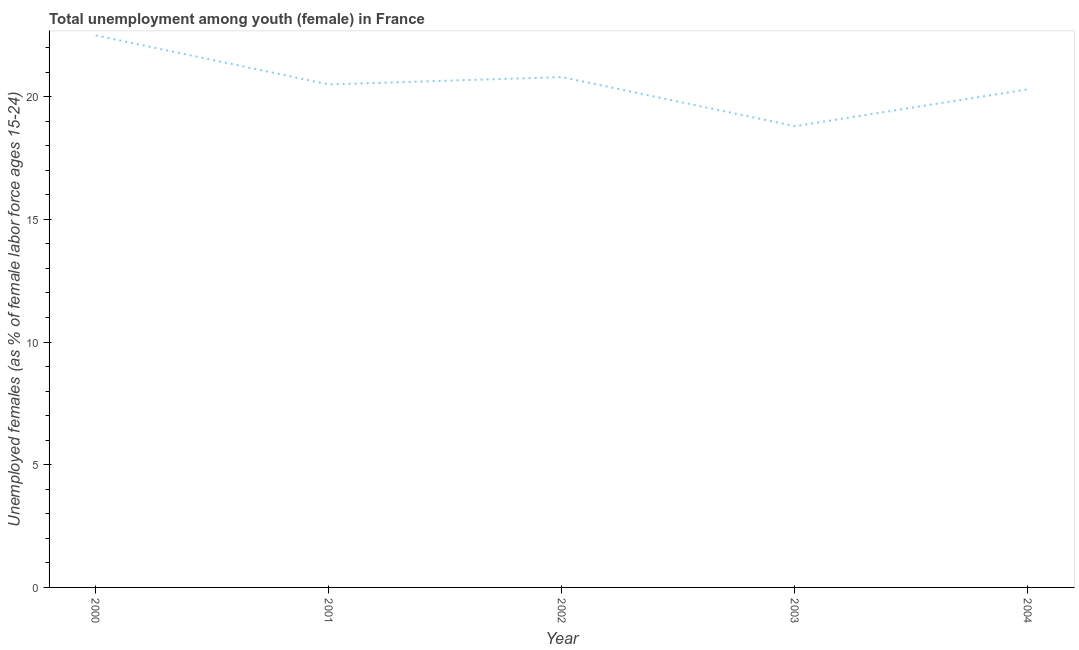What is the unemployed female youth population in 2002?
Give a very brief answer. 20.8. Across all years, what is the minimum unemployed female youth population?
Offer a very short reply. 18.8. What is the sum of the unemployed female youth population?
Offer a very short reply. 102.9. What is the difference between the unemployed female youth population in 2001 and 2003?
Make the answer very short. 1.7. What is the average unemployed female youth population per year?
Your response must be concise. 20.58. What is the median unemployed female youth population?
Give a very brief answer. 20.5. What is the ratio of the unemployed female youth population in 2002 to that in 2003?
Ensure brevity in your answer.  1.11. Is the difference between the unemployed female youth population in 2001 and 2002 greater than the difference between any two years?
Provide a short and direct response. No. What is the difference between the highest and the second highest unemployed female youth population?
Provide a short and direct response. 1.7. Is the sum of the unemployed female youth population in 2003 and 2004 greater than the maximum unemployed female youth population across all years?
Offer a terse response. Yes. What is the difference between the highest and the lowest unemployed female youth population?
Your answer should be very brief. 3.7. Does the unemployed female youth population monotonically increase over the years?
Provide a succinct answer. No. How many lines are there?
Offer a terse response. 1. How many years are there in the graph?
Offer a very short reply. 5. What is the title of the graph?
Offer a terse response. Total unemployment among youth (female) in France. What is the label or title of the X-axis?
Give a very brief answer. Year. What is the label or title of the Y-axis?
Give a very brief answer. Unemployed females (as % of female labor force ages 15-24). What is the Unemployed females (as % of female labor force ages 15-24) of 2001?
Keep it short and to the point. 20.5. What is the Unemployed females (as % of female labor force ages 15-24) of 2002?
Your response must be concise. 20.8. What is the Unemployed females (as % of female labor force ages 15-24) of 2003?
Your answer should be compact. 18.8. What is the Unemployed females (as % of female labor force ages 15-24) in 2004?
Your answer should be compact. 20.3. What is the difference between the Unemployed females (as % of female labor force ages 15-24) in 2000 and 2001?
Your response must be concise. 2. What is the difference between the Unemployed females (as % of female labor force ages 15-24) in 2000 and 2003?
Offer a very short reply. 3.7. What is the difference between the Unemployed females (as % of female labor force ages 15-24) in 2002 and 2003?
Keep it short and to the point. 2. What is the ratio of the Unemployed females (as % of female labor force ages 15-24) in 2000 to that in 2001?
Give a very brief answer. 1.1. What is the ratio of the Unemployed females (as % of female labor force ages 15-24) in 2000 to that in 2002?
Keep it short and to the point. 1.08. What is the ratio of the Unemployed females (as % of female labor force ages 15-24) in 2000 to that in 2003?
Provide a succinct answer. 1.2. What is the ratio of the Unemployed females (as % of female labor force ages 15-24) in 2000 to that in 2004?
Your answer should be compact. 1.11. What is the ratio of the Unemployed females (as % of female labor force ages 15-24) in 2001 to that in 2003?
Keep it short and to the point. 1.09. What is the ratio of the Unemployed females (as % of female labor force ages 15-24) in 2001 to that in 2004?
Your response must be concise. 1.01. What is the ratio of the Unemployed females (as % of female labor force ages 15-24) in 2002 to that in 2003?
Offer a terse response. 1.11. What is the ratio of the Unemployed females (as % of female labor force ages 15-24) in 2002 to that in 2004?
Your answer should be very brief. 1.02. What is the ratio of the Unemployed females (as % of female labor force ages 15-24) in 2003 to that in 2004?
Your answer should be very brief. 0.93. 